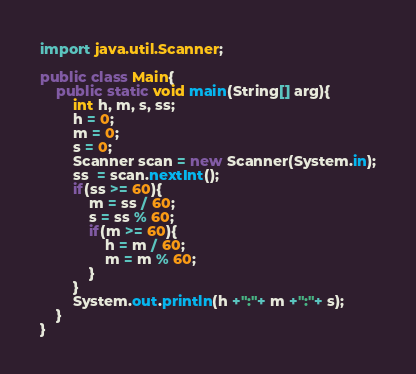<code> <loc_0><loc_0><loc_500><loc_500><_Java_>import java.util.Scanner;

public class Main{
    public static void main(String[] arg){
        int h, m, s, ss;
        h = 0;
        m = 0;
        s = 0;
        Scanner scan = new Scanner(System.in);
        ss  = scan.nextInt();
        if(ss >= 60){
            m = ss / 60;
            s = ss % 60;
            if(m >= 60){
                h = m / 60;
                m = m % 60;
            }
        }
        System.out.println(h +":"+ m +":"+ s);
    }
}
</code> 